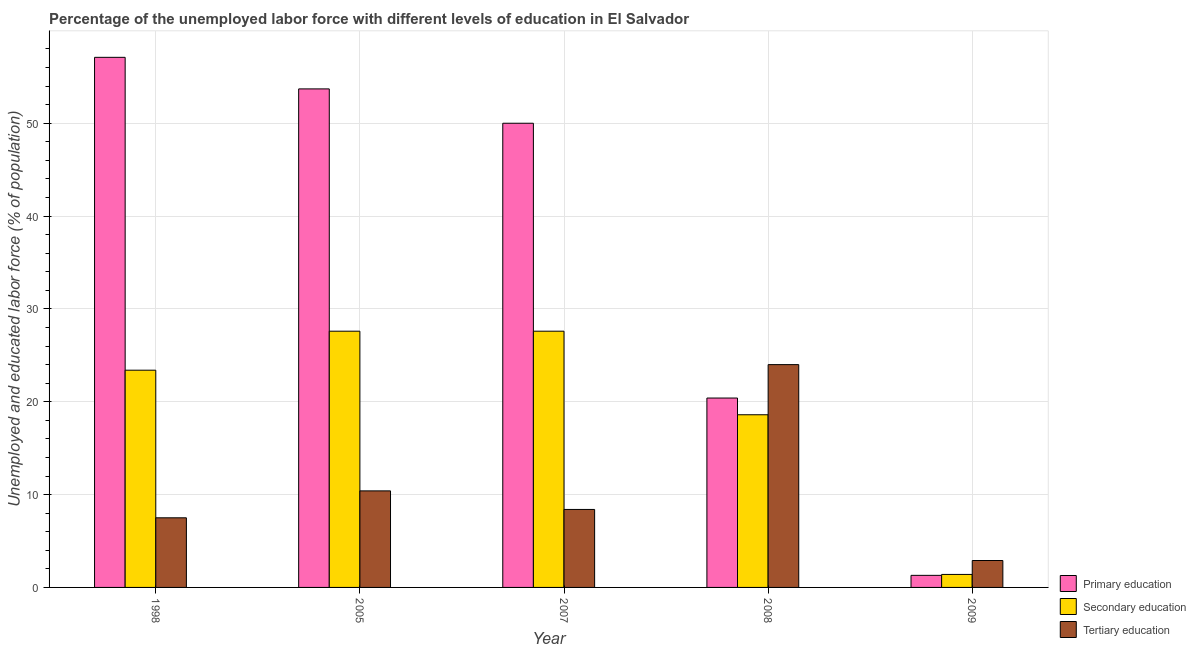How many different coloured bars are there?
Offer a very short reply. 3. Are the number of bars on each tick of the X-axis equal?
Your answer should be compact. Yes. How many bars are there on the 3rd tick from the right?
Ensure brevity in your answer.  3. What is the percentage of labor force who received tertiary education in 2007?
Provide a succinct answer. 8.4. Across all years, what is the minimum percentage of labor force who received primary education?
Give a very brief answer. 1.3. In which year was the percentage of labor force who received tertiary education maximum?
Your response must be concise. 2008. What is the total percentage of labor force who received tertiary education in the graph?
Your answer should be compact. 53.2. What is the difference between the percentage of labor force who received primary education in 2005 and that in 2008?
Give a very brief answer. 33.3. What is the difference between the percentage of labor force who received primary education in 2008 and the percentage of labor force who received secondary education in 1998?
Provide a succinct answer. -36.7. What is the average percentage of labor force who received primary education per year?
Keep it short and to the point. 36.5. What is the ratio of the percentage of labor force who received secondary education in 1998 to that in 2007?
Your answer should be compact. 0.85. Is the difference between the percentage of labor force who received tertiary education in 2005 and 2007 greater than the difference between the percentage of labor force who received primary education in 2005 and 2007?
Keep it short and to the point. No. What is the difference between the highest and the second highest percentage of labor force who received secondary education?
Give a very brief answer. 0. What is the difference between the highest and the lowest percentage of labor force who received secondary education?
Provide a succinct answer. 26.2. Is the sum of the percentage of labor force who received tertiary education in 2007 and 2009 greater than the maximum percentage of labor force who received primary education across all years?
Your answer should be very brief. No. What does the 2nd bar from the left in 2008 represents?
Provide a succinct answer. Secondary education. What does the 3rd bar from the right in 2008 represents?
Give a very brief answer. Primary education. Is it the case that in every year, the sum of the percentage of labor force who received primary education and percentage of labor force who received secondary education is greater than the percentage of labor force who received tertiary education?
Offer a very short reply. No. Are all the bars in the graph horizontal?
Your response must be concise. No. What is the difference between two consecutive major ticks on the Y-axis?
Your answer should be very brief. 10. Are the values on the major ticks of Y-axis written in scientific E-notation?
Your response must be concise. No. How many legend labels are there?
Give a very brief answer. 3. What is the title of the graph?
Your answer should be compact. Percentage of the unemployed labor force with different levels of education in El Salvador. What is the label or title of the Y-axis?
Ensure brevity in your answer.  Unemployed and educated labor force (% of population). What is the Unemployed and educated labor force (% of population) in Primary education in 1998?
Make the answer very short. 57.1. What is the Unemployed and educated labor force (% of population) of Secondary education in 1998?
Offer a terse response. 23.4. What is the Unemployed and educated labor force (% of population) in Primary education in 2005?
Give a very brief answer. 53.7. What is the Unemployed and educated labor force (% of population) in Secondary education in 2005?
Offer a very short reply. 27.6. What is the Unemployed and educated labor force (% of population) in Tertiary education in 2005?
Make the answer very short. 10.4. What is the Unemployed and educated labor force (% of population) in Secondary education in 2007?
Your answer should be compact. 27.6. What is the Unemployed and educated labor force (% of population) in Tertiary education in 2007?
Offer a very short reply. 8.4. What is the Unemployed and educated labor force (% of population) in Primary education in 2008?
Your response must be concise. 20.4. What is the Unemployed and educated labor force (% of population) of Secondary education in 2008?
Ensure brevity in your answer.  18.6. What is the Unemployed and educated labor force (% of population) of Primary education in 2009?
Your answer should be very brief. 1.3. What is the Unemployed and educated labor force (% of population) of Secondary education in 2009?
Give a very brief answer. 1.4. What is the Unemployed and educated labor force (% of population) in Tertiary education in 2009?
Make the answer very short. 2.9. Across all years, what is the maximum Unemployed and educated labor force (% of population) in Primary education?
Make the answer very short. 57.1. Across all years, what is the maximum Unemployed and educated labor force (% of population) of Secondary education?
Offer a very short reply. 27.6. Across all years, what is the maximum Unemployed and educated labor force (% of population) of Tertiary education?
Your answer should be compact. 24. Across all years, what is the minimum Unemployed and educated labor force (% of population) in Primary education?
Keep it short and to the point. 1.3. Across all years, what is the minimum Unemployed and educated labor force (% of population) in Secondary education?
Your response must be concise. 1.4. Across all years, what is the minimum Unemployed and educated labor force (% of population) in Tertiary education?
Your answer should be compact. 2.9. What is the total Unemployed and educated labor force (% of population) in Primary education in the graph?
Ensure brevity in your answer.  182.5. What is the total Unemployed and educated labor force (% of population) of Secondary education in the graph?
Provide a short and direct response. 98.6. What is the total Unemployed and educated labor force (% of population) of Tertiary education in the graph?
Your answer should be very brief. 53.2. What is the difference between the Unemployed and educated labor force (% of population) in Primary education in 1998 and that in 2005?
Keep it short and to the point. 3.4. What is the difference between the Unemployed and educated labor force (% of population) in Secondary education in 1998 and that in 2005?
Provide a short and direct response. -4.2. What is the difference between the Unemployed and educated labor force (% of population) in Tertiary education in 1998 and that in 2005?
Keep it short and to the point. -2.9. What is the difference between the Unemployed and educated labor force (% of population) in Primary education in 1998 and that in 2007?
Provide a short and direct response. 7.1. What is the difference between the Unemployed and educated labor force (% of population) of Tertiary education in 1998 and that in 2007?
Offer a terse response. -0.9. What is the difference between the Unemployed and educated labor force (% of population) of Primary education in 1998 and that in 2008?
Give a very brief answer. 36.7. What is the difference between the Unemployed and educated labor force (% of population) in Secondary education in 1998 and that in 2008?
Make the answer very short. 4.8. What is the difference between the Unemployed and educated labor force (% of population) of Tertiary education in 1998 and that in 2008?
Give a very brief answer. -16.5. What is the difference between the Unemployed and educated labor force (% of population) in Primary education in 1998 and that in 2009?
Ensure brevity in your answer.  55.8. What is the difference between the Unemployed and educated labor force (% of population) in Tertiary education in 1998 and that in 2009?
Your answer should be very brief. 4.6. What is the difference between the Unemployed and educated labor force (% of population) of Primary education in 2005 and that in 2007?
Make the answer very short. 3.7. What is the difference between the Unemployed and educated labor force (% of population) of Secondary education in 2005 and that in 2007?
Keep it short and to the point. 0. What is the difference between the Unemployed and educated labor force (% of population) in Tertiary education in 2005 and that in 2007?
Keep it short and to the point. 2. What is the difference between the Unemployed and educated labor force (% of population) in Primary education in 2005 and that in 2008?
Give a very brief answer. 33.3. What is the difference between the Unemployed and educated labor force (% of population) of Secondary education in 2005 and that in 2008?
Offer a terse response. 9. What is the difference between the Unemployed and educated labor force (% of population) of Tertiary education in 2005 and that in 2008?
Ensure brevity in your answer.  -13.6. What is the difference between the Unemployed and educated labor force (% of population) of Primary education in 2005 and that in 2009?
Your answer should be compact. 52.4. What is the difference between the Unemployed and educated labor force (% of population) of Secondary education in 2005 and that in 2009?
Provide a succinct answer. 26.2. What is the difference between the Unemployed and educated labor force (% of population) in Tertiary education in 2005 and that in 2009?
Make the answer very short. 7.5. What is the difference between the Unemployed and educated labor force (% of population) in Primary education in 2007 and that in 2008?
Your answer should be compact. 29.6. What is the difference between the Unemployed and educated labor force (% of population) in Secondary education in 2007 and that in 2008?
Give a very brief answer. 9. What is the difference between the Unemployed and educated labor force (% of population) of Tertiary education in 2007 and that in 2008?
Keep it short and to the point. -15.6. What is the difference between the Unemployed and educated labor force (% of population) of Primary education in 2007 and that in 2009?
Provide a short and direct response. 48.7. What is the difference between the Unemployed and educated labor force (% of population) in Secondary education in 2007 and that in 2009?
Provide a succinct answer. 26.2. What is the difference between the Unemployed and educated labor force (% of population) of Primary education in 2008 and that in 2009?
Make the answer very short. 19.1. What is the difference between the Unemployed and educated labor force (% of population) of Secondary education in 2008 and that in 2009?
Ensure brevity in your answer.  17.2. What is the difference between the Unemployed and educated labor force (% of population) in Tertiary education in 2008 and that in 2009?
Your answer should be very brief. 21.1. What is the difference between the Unemployed and educated labor force (% of population) in Primary education in 1998 and the Unemployed and educated labor force (% of population) in Secondary education in 2005?
Offer a very short reply. 29.5. What is the difference between the Unemployed and educated labor force (% of population) of Primary education in 1998 and the Unemployed and educated labor force (% of population) of Tertiary education in 2005?
Your answer should be compact. 46.7. What is the difference between the Unemployed and educated labor force (% of population) of Primary education in 1998 and the Unemployed and educated labor force (% of population) of Secondary education in 2007?
Ensure brevity in your answer.  29.5. What is the difference between the Unemployed and educated labor force (% of population) in Primary education in 1998 and the Unemployed and educated labor force (% of population) in Tertiary education in 2007?
Keep it short and to the point. 48.7. What is the difference between the Unemployed and educated labor force (% of population) of Primary education in 1998 and the Unemployed and educated labor force (% of population) of Secondary education in 2008?
Your response must be concise. 38.5. What is the difference between the Unemployed and educated labor force (% of population) of Primary education in 1998 and the Unemployed and educated labor force (% of population) of Tertiary education in 2008?
Your answer should be very brief. 33.1. What is the difference between the Unemployed and educated labor force (% of population) of Primary education in 1998 and the Unemployed and educated labor force (% of population) of Secondary education in 2009?
Provide a short and direct response. 55.7. What is the difference between the Unemployed and educated labor force (% of population) of Primary education in 1998 and the Unemployed and educated labor force (% of population) of Tertiary education in 2009?
Provide a short and direct response. 54.2. What is the difference between the Unemployed and educated labor force (% of population) in Secondary education in 1998 and the Unemployed and educated labor force (% of population) in Tertiary education in 2009?
Give a very brief answer. 20.5. What is the difference between the Unemployed and educated labor force (% of population) in Primary education in 2005 and the Unemployed and educated labor force (% of population) in Secondary education in 2007?
Offer a terse response. 26.1. What is the difference between the Unemployed and educated labor force (% of population) in Primary education in 2005 and the Unemployed and educated labor force (% of population) in Tertiary education in 2007?
Your response must be concise. 45.3. What is the difference between the Unemployed and educated labor force (% of population) of Secondary education in 2005 and the Unemployed and educated labor force (% of population) of Tertiary education in 2007?
Provide a short and direct response. 19.2. What is the difference between the Unemployed and educated labor force (% of population) in Primary education in 2005 and the Unemployed and educated labor force (% of population) in Secondary education in 2008?
Ensure brevity in your answer.  35.1. What is the difference between the Unemployed and educated labor force (% of population) of Primary education in 2005 and the Unemployed and educated labor force (% of population) of Tertiary education in 2008?
Offer a very short reply. 29.7. What is the difference between the Unemployed and educated labor force (% of population) in Primary education in 2005 and the Unemployed and educated labor force (% of population) in Secondary education in 2009?
Provide a short and direct response. 52.3. What is the difference between the Unemployed and educated labor force (% of population) of Primary education in 2005 and the Unemployed and educated labor force (% of population) of Tertiary education in 2009?
Offer a terse response. 50.8. What is the difference between the Unemployed and educated labor force (% of population) in Secondary education in 2005 and the Unemployed and educated labor force (% of population) in Tertiary education in 2009?
Keep it short and to the point. 24.7. What is the difference between the Unemployed and educated labor force (% of population) in Primary education in 2007 and the Unemployed and educated labor force (% of population) in Secondary education in 2008?
Keep it short and to the point. 31.4. What is the difference between the Unemployed and educated labor force (% of population) of Primary education in 2007 and the Unemployed and educated labor force (% of population) of Secondary education in 2009?
Provide a succinct answer. 48.6. What is the difference between the Unemployed and educated labor force (% of population) of Primary education in 2007 and the Unemployed and educated labor force (% of population) of Tertiary education in 2009?
Offer a terse response. 47.1. What is the difference between the Unemployed and educated labor force (% of population) of Secondary education in 2007 and the Unemployed and educated labor force (% of population) of Tertiary education in 2009?
Your answer should be compact. 24.7. What is the difference between the Unemployed and educated labor force (% of population) in Primary education in 2008 and the Unemployed and educated labor force (% of population) in Secondary education in 2009?
Provide a succinct answer. 19. What is the difference between the Unemployed and educated labor force (% of population) in Primary education in 2008 and the Unemployed and educated labor force (% of population) in Tertiary education in 2009?
Make the answer very short. 17.5. What is the difference between the Unemployed and educated labor force (% of population) of Secondary education in 2008 and the Unemployed and educated labor force (% of population) of Tertiary education in 2009?
Make the answer very short. 15.7. What is the average Unemployed and educated labor force (% of population) in Primary education per year?
Make the answer very short. 36.5. What is the average Unemployed and educated labor force (% of population) of Secondary education per year?
Your response must be concise. 19.72. What is the average Unemployed and educated labor force (% of population) in Tertiary education per year?
Keep it short and to the point. 10.64. In the year 1998, what is the difference between the Unemployed and educated labor force (% of population) of Primary education and Unemployed and educated labor force (% of population) of Secondary education?
Make the answer very short. 33.7. In the year 1998, what is the difference between the Unemployed and educated labor force (% of population) of Primary education and Unemployed and educated labor force (% of population) of Tertiary education?
Your answer should be very brief. 49.6. In the year 1998, what is the difference between the Unemployed and educated labor force (% of population) of Secondary education and Unemployed and educated labor force (% of population) of Tertiary education?
Provide a short and direct response. 15.9. In the year 2005, what is the difference between the Unemployed and educated labor force (% of population) of Primary education and Unemployed and educated labor force (% of population) of Secondary education?
Ensure brevity in your answer.  26.1. In the year 2005, what is the difference between the Unemployed and educated labor force (% of population) of Primary education and Unemployed and educated labor force (% of population) of Tertiary education?
Your answer should be compact. 43.3. In the year 2005, what is the difference between the Unemployed and educated labor force (% of population) of Secondary education and Unemployed and educated labor force (% of population) of Tertiary education?
Keep it short and to the point. 17.2. In the year 2007, what is the difference between the Unemployed and educated labor force (% of population) in Primary education and Unemployed and educated labor force (% of population) in Secondary education?
Offer a terse response. 22.4. In the year 2007, what is the difference between the Unemployed and educated labor force (% of population) in Primary education and Unemployed and educated labor force (% of population) in Tertiary education?
Provide a succinct answer. 41.6. In the year 2008, what is the difference between the Unemployed and educated labor force (% of population) in Primary education and Unemployed and educated labor force (% of population) in Secondary education?
Make the answer very short. 1.8. In the year 2008, what is the difference between the Unemployed and educated labor force (% of population) of Primary education and Unemployed and educated labor force (% of population) of Tertiary education?
Provide a short and direct response. -3.6. What is the ratio of the Unemployed and educated labor force (% of population) of Primary education in 1998 to that in 2005?
Offer a very short reply. 1.06. What is the ratio of the Unemployed and educated labor force (% of population) in Secondary education in 1998 to that in 2005?
Make the answer very short. 0.85. What is the ratio of the Unemployed and educated labor force (% of population) of Tertiary education in 1998 to that in 2005?
Your answer should be compact. 0.72. What is the ratio of the Unemployed and educated labor force (% of population) of Primary education in 1998 to that in 2007?
Ensure brevity in your answer.  1.14. What is the ratio of the Unemployed and educated labor force (% of population) in Secondary education in 1998 to that in 2007?
Provide a succinct answer. 0.85. What is the ratio of the Unemployed and educated labor force (% of population) of Tertiary education in 1998 to that in 2007?
Keep it short and to the point. 0.89. What is the ratio of the Unemployed and educated labor force (% of population) of Primary education in 1998 to that in 2008?
Offer a terse response. 2.8. What is the ratio of the Unemployed and educated labor force (% of population) of Secondary education in 1998 to that in 2008?
Provide a succinct answer. 1.26. What is the ratio of the Unemployed and educated labor force (% of population) in Tertiary education in 1998 to that in 2008?
Your answer should be very brief. 0.31. What is the ratio of the Unemployed and educated labor force (% of population) in Primary education in 1998 to that in 2009?
Your answer should be compact. 43.92. What is the ratio of the Unemployed and educated labor force (% of population) in Secondary education in 1998 to that in 2009?
Provide a succinct answer. 16.71. What is the ratio of the Unemployed and educated labor force (% of population) of Tertiary education in 1998 to that in 2009?
Your answer should be very brief. 2.59. What is the ratio of the Unemployed and educated labor force (% of population) of Primary education in 2005 to that in 2007?
Your response must be concise. 1.07. What is the ratio of the Unemployed and educated labor force (% of population) in Secondary education in 2005 to that in 2007?
Provide a succinct answer. 1. What is the ratio of the Unemployed and educated labor force (% of population) in Tertiary education in 2005 to that in 2007?
Offer a very short reply. 1.24. What is the ratio of the Unemployed and educated labor force (% of population) of Primary education in 2005 to that in 2008?
Your response must be concise. 2.63. What is the ratio of the Unemployed and educated labor force (% of population) in Secondary education in 2005 to that in 2008?
Offer a very short reply. 1.48. What is the ratio of the Unemployed and educated labor force (% of population) in Tertiary education in 2005 to that in 2008?
Your response must be concise. 0.43. What is the ratio of the Unemployed and educated labor force (% of population) of Primary education in 2005 to that in 2009?
Offer a very short reply. 41.31. What is the ratio of the Unemployed and educated labor force (% of population) of Secondary education in 2005 to that in 2009?
Ensure brevity in your answer.  19.71. What is the ratio of the Unemployed and educated labor force (% of population) in Tertiary education in 2005 to that in 2009?
Keep it short and to the point. 3.59. What is the ratio of the Unemployed and educated labor force (% of population) of Primary education in 2007 to that in 2008?
Give a very brief answer. 2.45. What is the ratio of the Unemployed and educated labor force (% of population) of Secondary education in 2007 to that in 2008?
Keep it short and to the point. 1.48. What is the ratio of the Unemployed and educated labor force (% of population) in Tertiary education in 2007 to that in 2008?
Keep it short and to the point. 0.35. What is the ratio of the Unemployed and educated labor force (% of population) in Primary education in 2007 to that in 2009?
Provide a short and direct response. 38.46. What is the ratio of the Unemployed and educated labor force (% of population) of Secondary education in 2007 to that in 2009?
Provide a succinct answer. 19.71. What is the ratio of the Unemployed and educated labor force (% of population) of Tertiary education in 2007 to that in 2009?
Your answer should be very brief. 2.9. What is the ratio of the Unemployed and educated labor force (% of population) in Primary education in 2008 to that in 2009?
Keep it short and to the point. 15.69. What is the ratio of the Unemployed and educated labor force (% of population) in Secondary education in 2008 to that in 2009?
Offer a terse response. 13.29. What is the ratio of the Unemployed and educated labor force (% of population) of Tertiary education in 2008 to that in 2009?
Make the answer very short. 8.28. What is the difference between the highest and the lowest Unemployed and educated labor force (% of population) in Primary education?
Provide a short and direct response. 55.8. What is the difference between the highest and the lowest Unemployed and educated labor force (% of population) in Secondary education?
Ensure brevity in your answer.  26.2. What is the difference between the highest and the lowest Unemployed and educated labor force (% of population) in Tertiary education?
Ensure brevity in your answer.  21.1. 